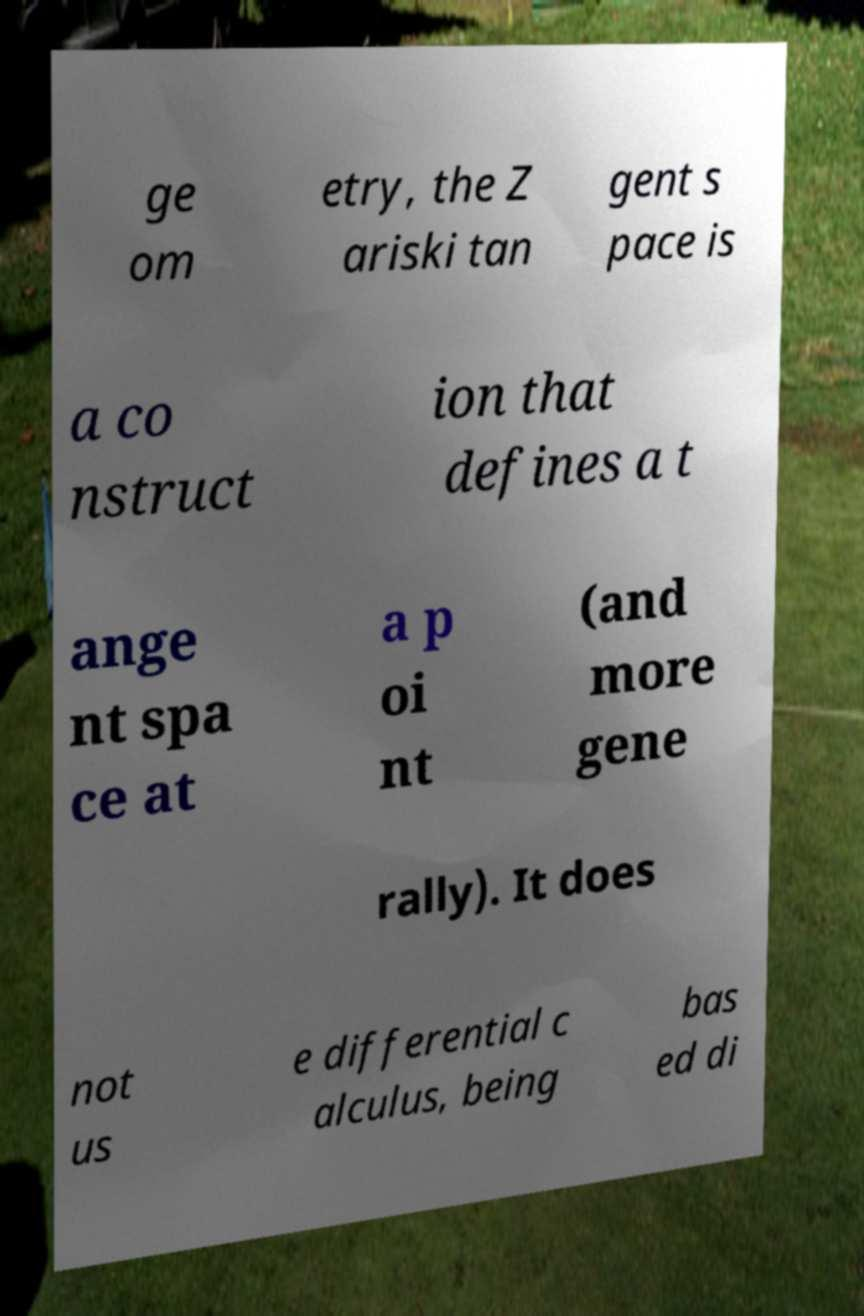Could you assist in decoding the text presented in this image and type it out clearly? ge om etry, the Z ariski tan gent s pace is a co nstruct ion that defines a t ange nt spa ce at a p oi nt (and more gene rally). It does not us e differential c alculus, being bas ed di 